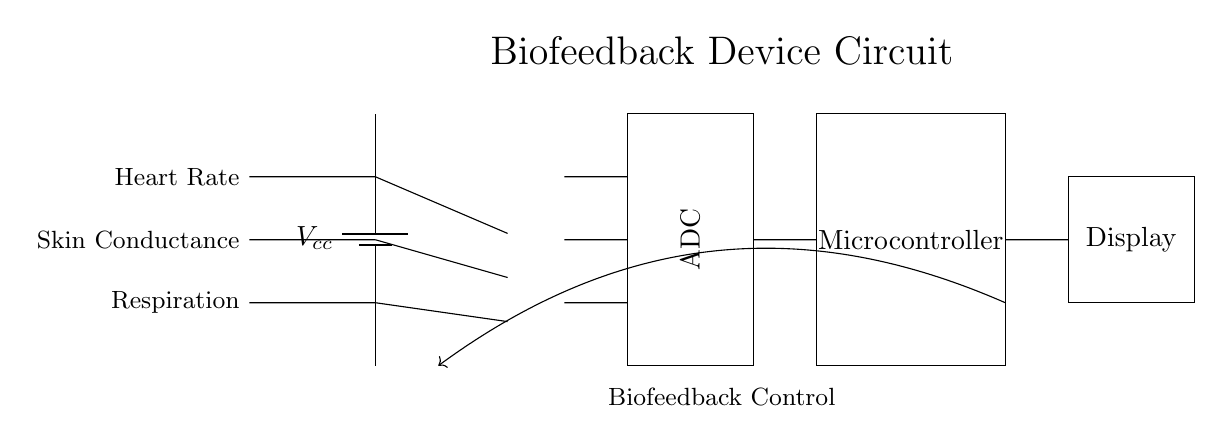What components are used to measure physiological responses? The components include heart rate, skin conductance, and respiration sensors, as indicated by the labels on the left side of the circuit.
Answer: Heart rate, skin conductance, respiration What is the role of the operational amplifiers in this circuit? The operational amplifiers amplify the signals from the physiological sensors before passing them to the analog-to-digital converter, as seen from the connections.
Answer: Amplify signals How many sensor inputs are there in this circuit? There are three sensor inputs for heart rate, skin conductance, and respiration, based on the labels shown in the diagram.
Answer: Three What does the ADC stand for in this circuit? ADC stands for Analog-to-Digital Converter, as marked in the rectangle positioned between the amplifiers and microcontroller.
Answer: Analog-to-Digital Converter What component follows the ADC in the circuit? The microcontroller follows the ADC, as indicated by the connection between the two components and the rectangular shape representing each unit.
Answer: Microcontroller Where is the biofeedback control loop indicated in the circuit? The feedback loop is shown with a line that bends from the microcontroller back to the input of the circuit, denoted by the arrow and its label in the diagram.
Answer: Biofeedback Control 